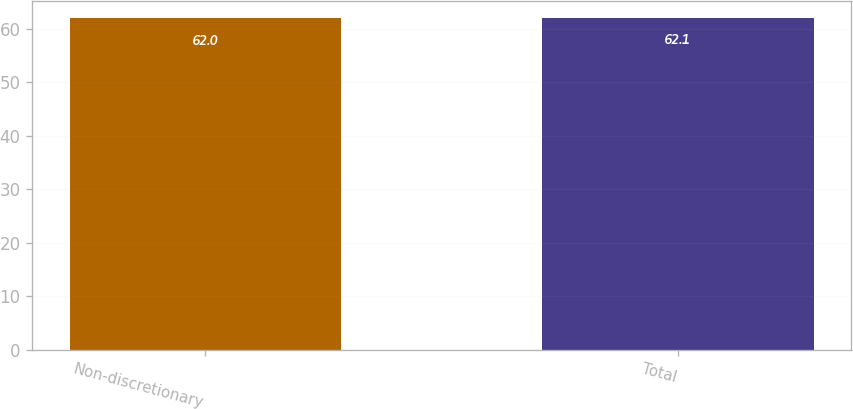<chart> <loc_0><loc_0><loc_500><loc_500><bar_chart><fcel>Non-discretionary<fcel>Total<nl><fcel>62<fcel>62.1<nl></chart> 